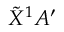Convert formula to latex. <formula><loc_0><loc_0><loc_500><loc_500>\tilde { X } ^ { 1 } A ^ { \prime }</formula> 